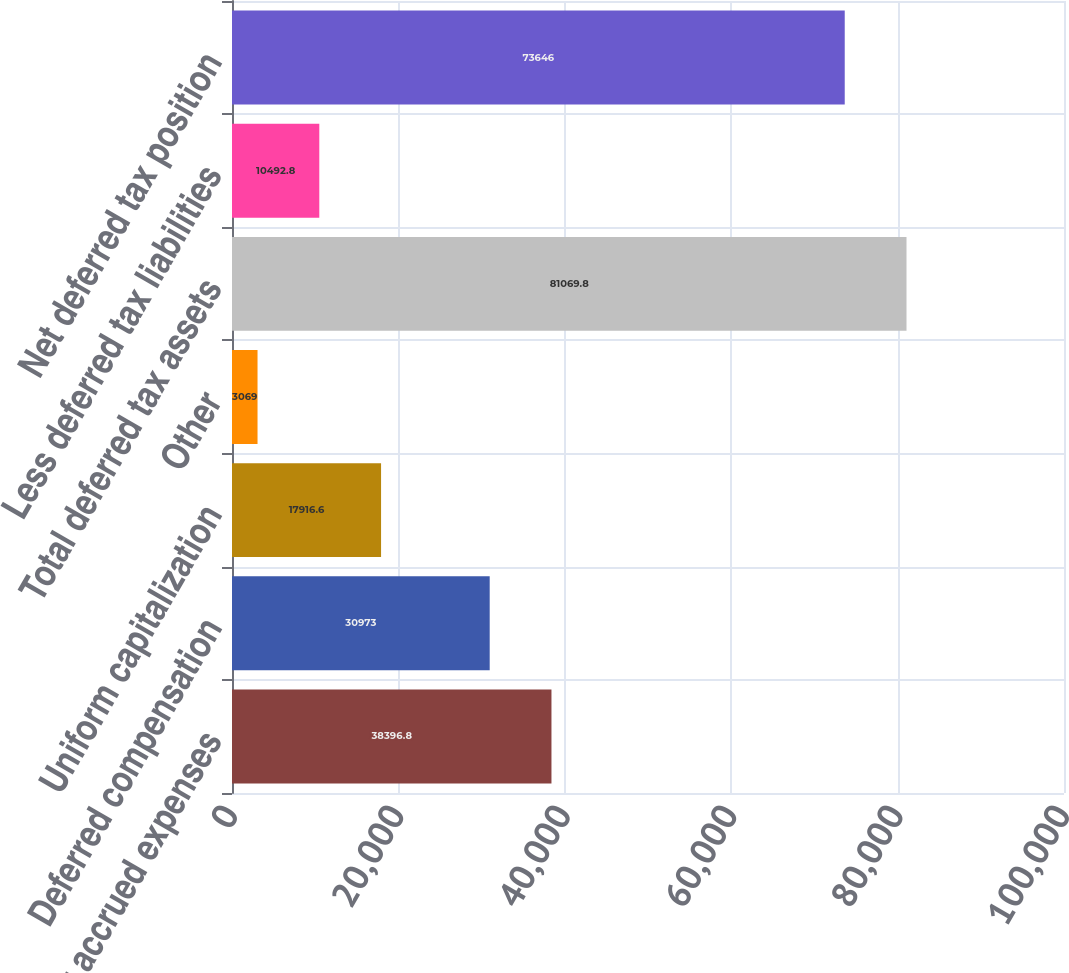<chart> <loc_0><loc_0><loc_500><loc_500><bar_chart><fcel>Other accrued expenses<fcel>Deferred compensation<fcel>Uniform capitalization<fcel>Other<fcel>Total deferred tax assets<fcel>Less deferred tax liabilities<fcel>Net deferred tax position<nl><fcel>38396.8<fcel>30973<fcel>17916.6<fcel>3069<fcel>81069.8<fcel>10492.8<fcel>73646<nl></chart> 